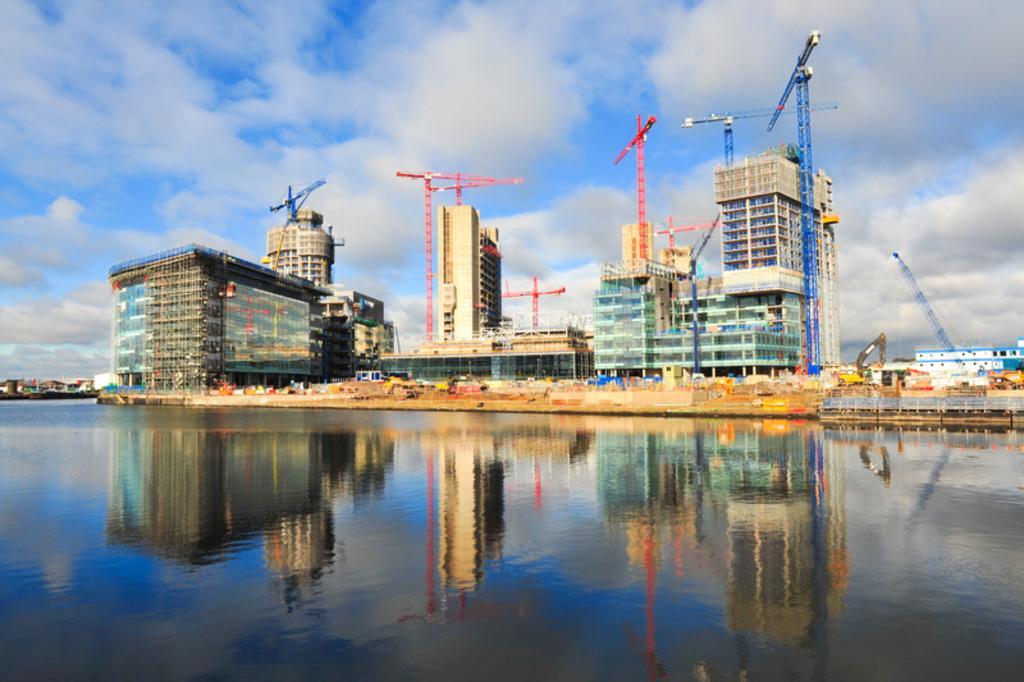Describe this image in one or two sentences. In this picture we can see many industrial buildings with machines and towers alongside a river. Here the sky is blue. 